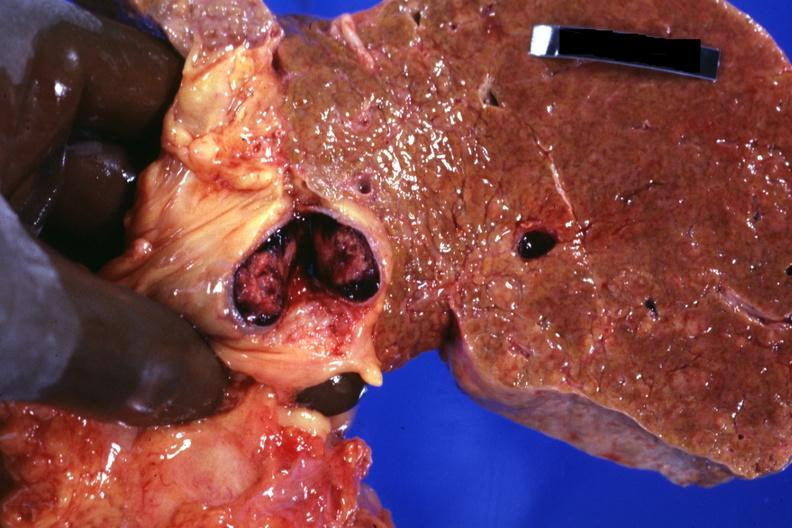what showing cirrhosis very well that appears to be micronodular and cross sectioned portal vein with obvious thrombus very good photo?
Answer the question using a single word or phrase. Frontal slab of liver 